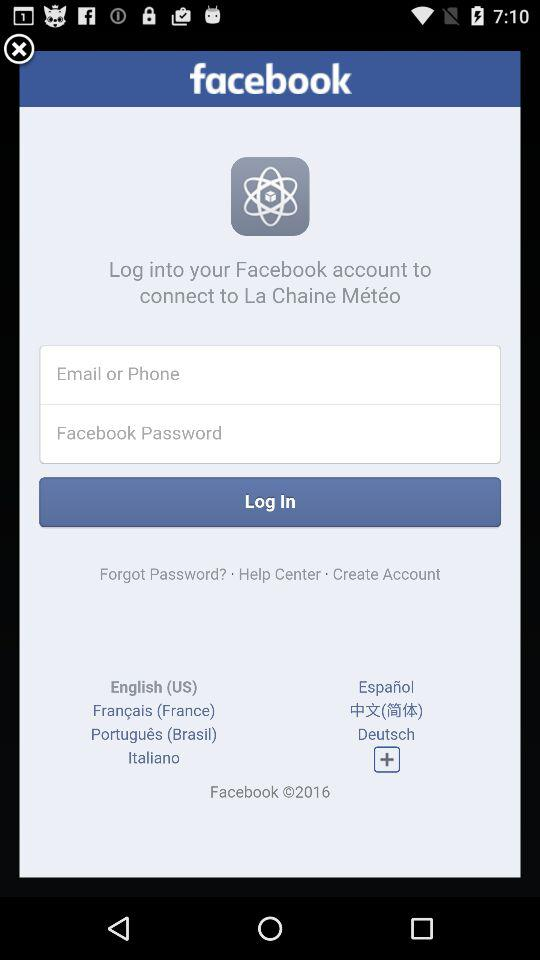What is the selected language? The selected language is English (US). 